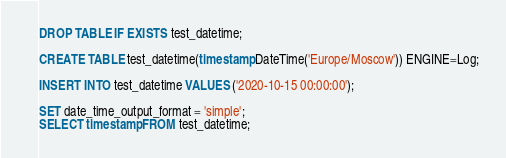Convert code to text. <code><loc_0><loc_0><loc_500><loc_500><_SQL_>DROP TABLE IF EXISTS test_datetime;

CREATE TABLE test_datetime(timestamp DateTime('Europe/Moscow')) ENGINE=Log;

INSERT INTO test_datetime VALUES ('2020-10-15 00:00:00');

SET date_time_output_format = 'simple';
SELECT timestamp FROM test_datetime;</code> 